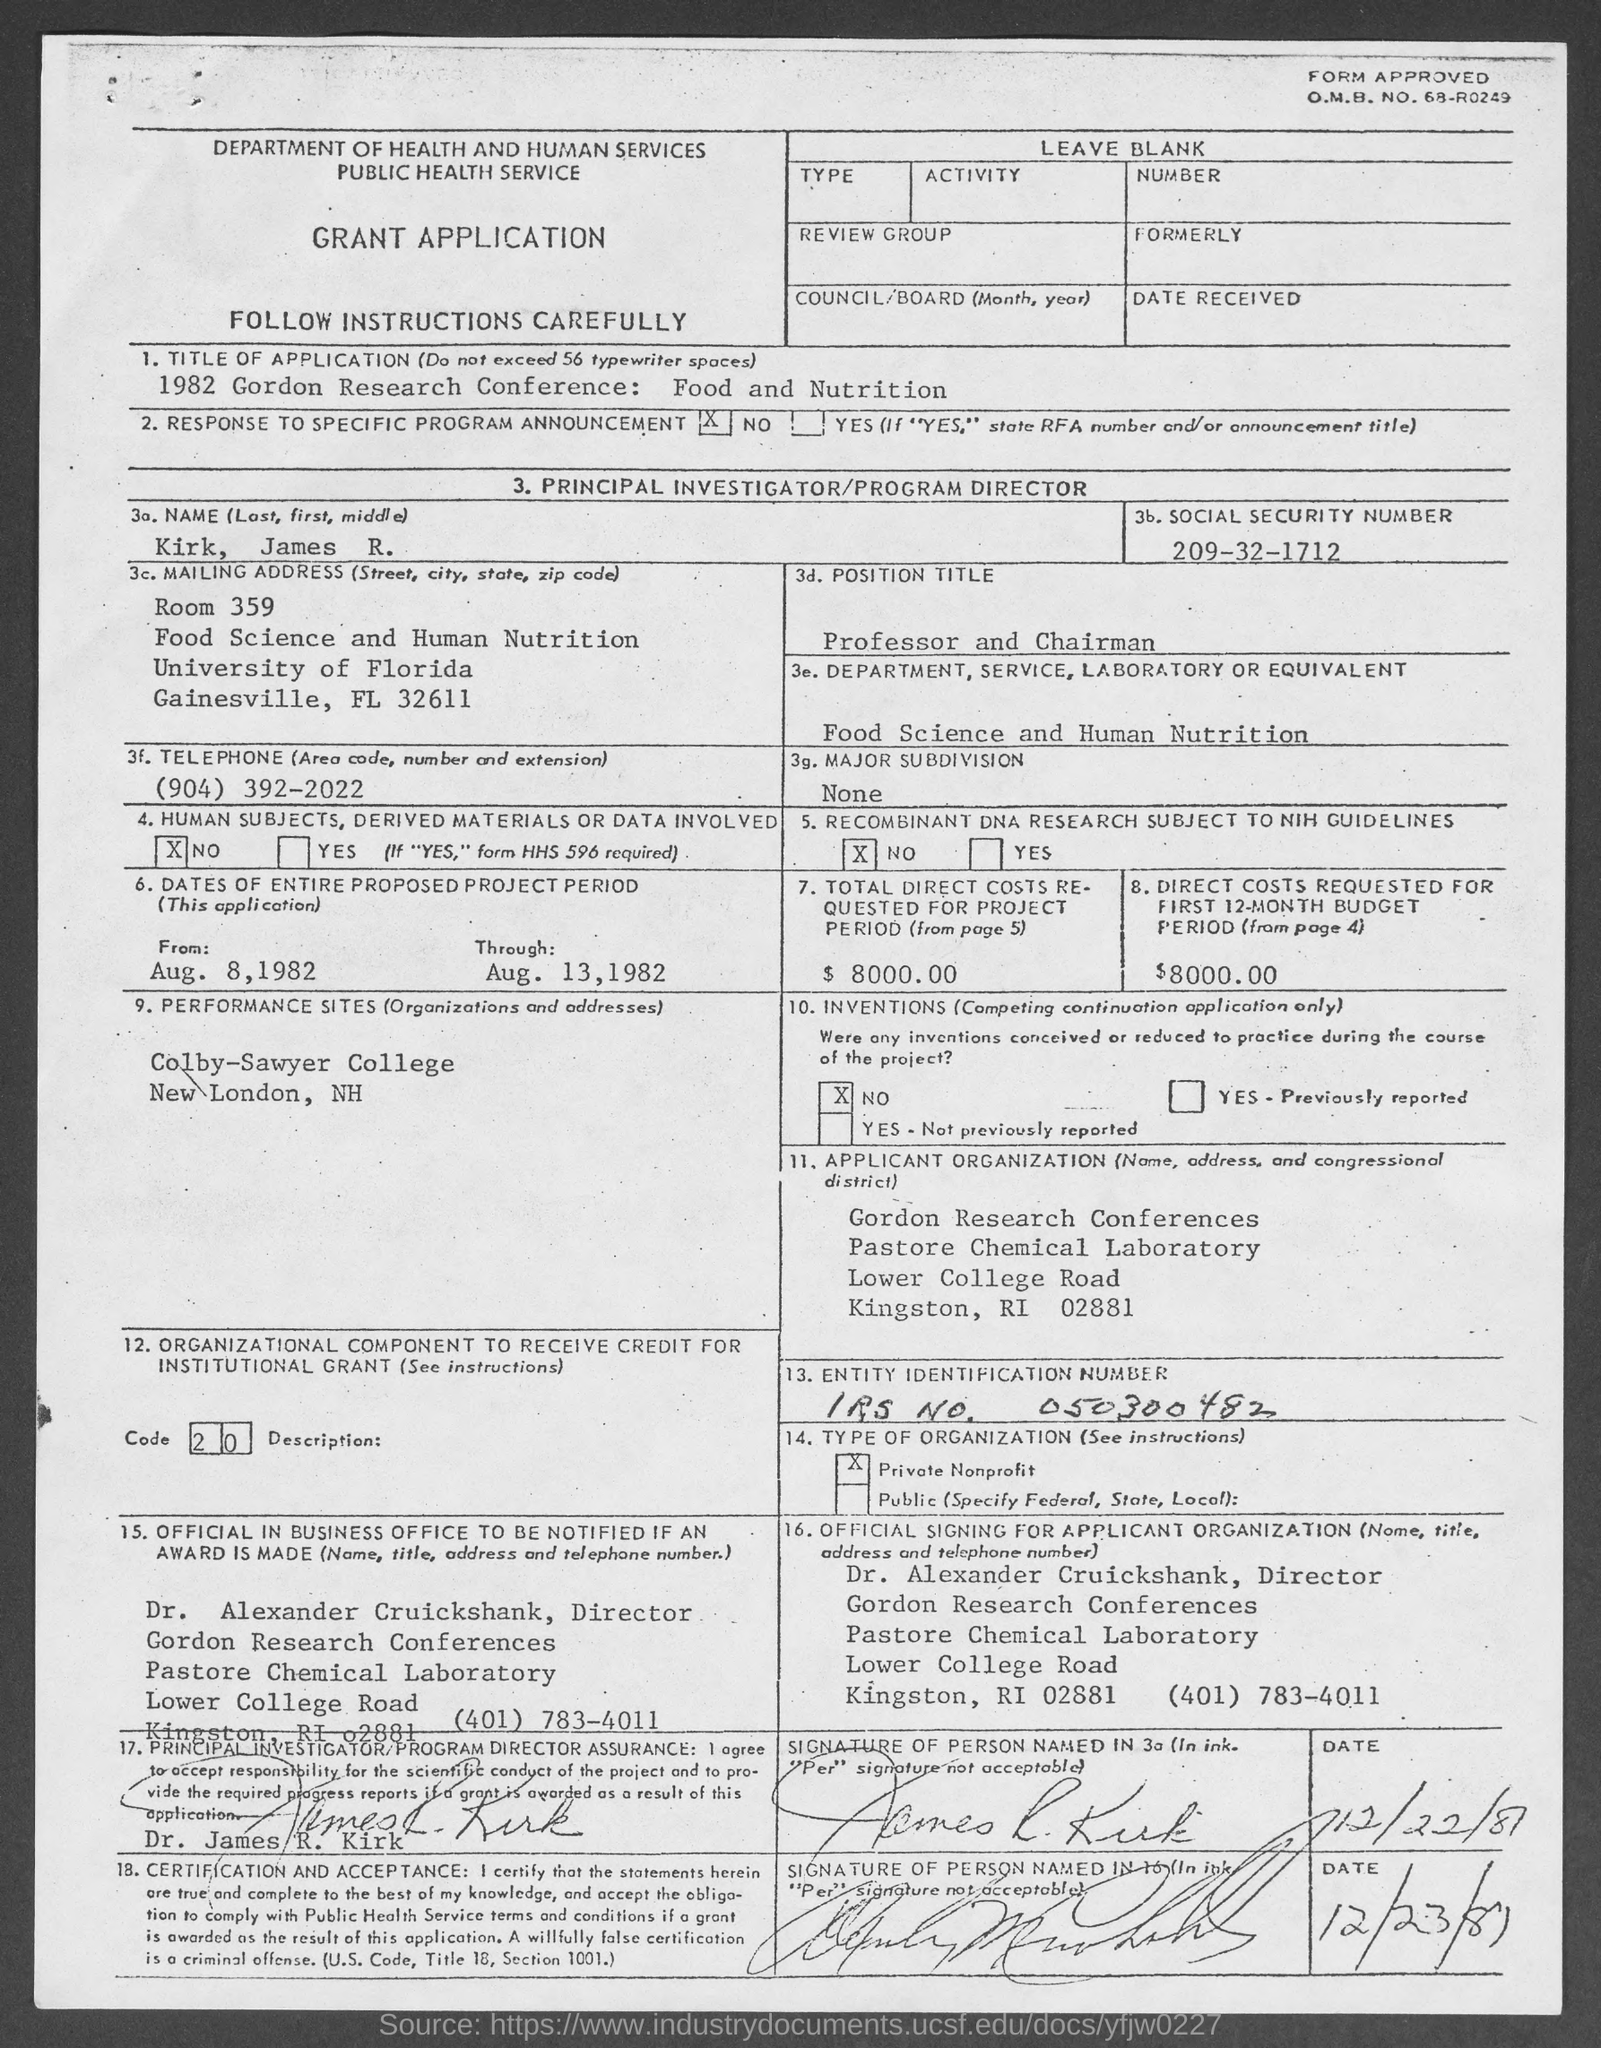Give some essential details in this illustration. The total direct costs requested for the project period are $8,000.00. Dr. Alexander Cruickshank can be contacted by telephone at (401) 783-4011. The social security number is 209-32-1712. The University of Florida is located in the state of Florida. The O.M.B. number is 68-R0249. 